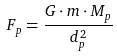Convert formula to latex. <formula><loc_0><loc_0><loc_500><loc_500>F _ { p } = \frac { G \cdot m \cdot M _ { p } } { d _ { p } ^ { 2 } }</formula> 